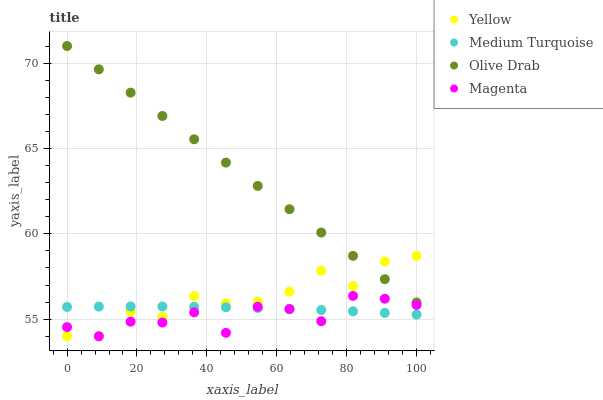Does Magenta have the minimum area under the curve?
Answer yes or no. Yes. Does Olive Drab have the maximum area under the curve?
Answer yes or no. Yes. Does Medium Turquoise have the minimum area under the curve?
Answer yes or no. No. Does Medium Turquoise have the maximum area under the curve?
Answer yes or no. No. Is Olive Drab the smoothest?
Answer yes or no. Yes. Is Magenta the roughest?
Answer yes or no. Yes. Is Medium Turquoise the smoothest?
Answer yes or no. No. Is Medium Turquoise the roughest?
Answer yes or no. No. Does Magenta have the lowest value?
Answer yes or no. Yes. Does Medium Turquoise have the lowest value?
Answer yes or no. No. Does Olive Drab have the highest value?
Answer yes or no. Yes. Does Magenta have the highest value?
Answer yes or no. No. Is Magenta less than Olive Drab?
Answer yes or no. Yes. Is Olive Drab greater than Magenta?
Answer yes or no. Yes. Does Medium Turquoise intersect Magenta?
Answer yes or no. Yes. Is Medium Turquoise less than Magenta?
Answer yes or no. No. Is Medium Turquoise greater than Magenta?
Answer yes or no. No. Does Magenta intersect Olive Drab?
Answer yes or no. No. 